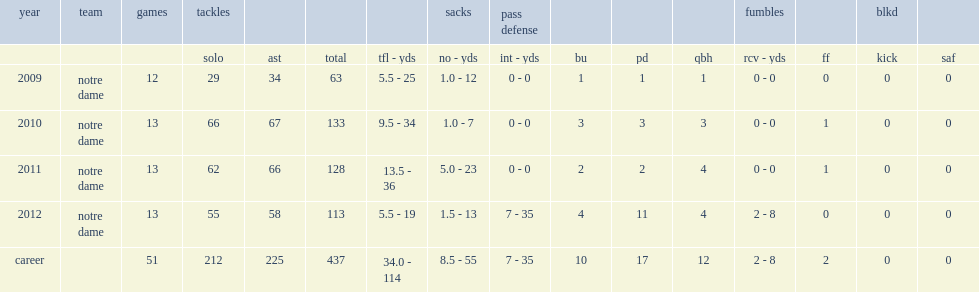How many tackles did manti te'o score in 2011? 128.0. 